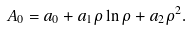<formula> <loc_0><loc_0><loc_500><loc_500>A _ { 0 } = a _ { 0 } + a _ { 1 } \rho \ln \rho + a _ { 2 } \rho ^ { 2 } .</formula> 